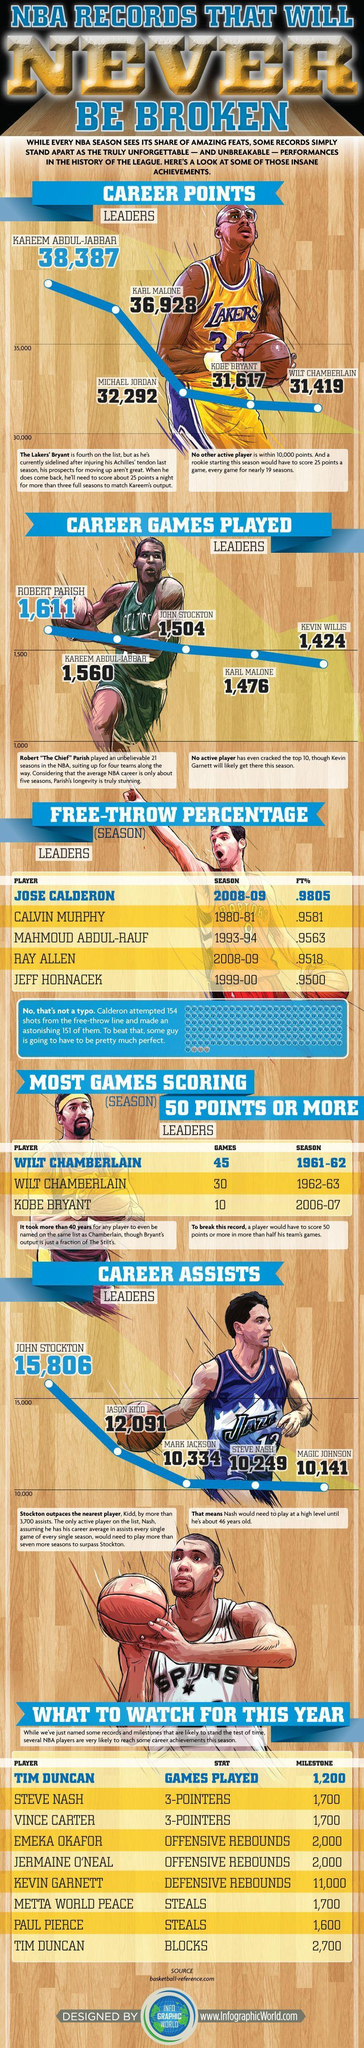What is the percentage listed on the third column and third row?
Answer the question with a short phrase. .9563 Which player scored the most number of games during 1961-63? Wilt Chamberlain What was the number of assists given by Magic Johnson, 10,141, 10,249, or 10,334? 10,141 What was the highest 3-pointers scored this year? 1,700 Which club did the player Robert Parish play for? Celtics Identify the player from the Raptors club shown in the image ? Jose Calderon Which player scored highest number of blocks and played the most number of games? TIM DUNCAN Which club did the player John Stockton play for? Jazz 